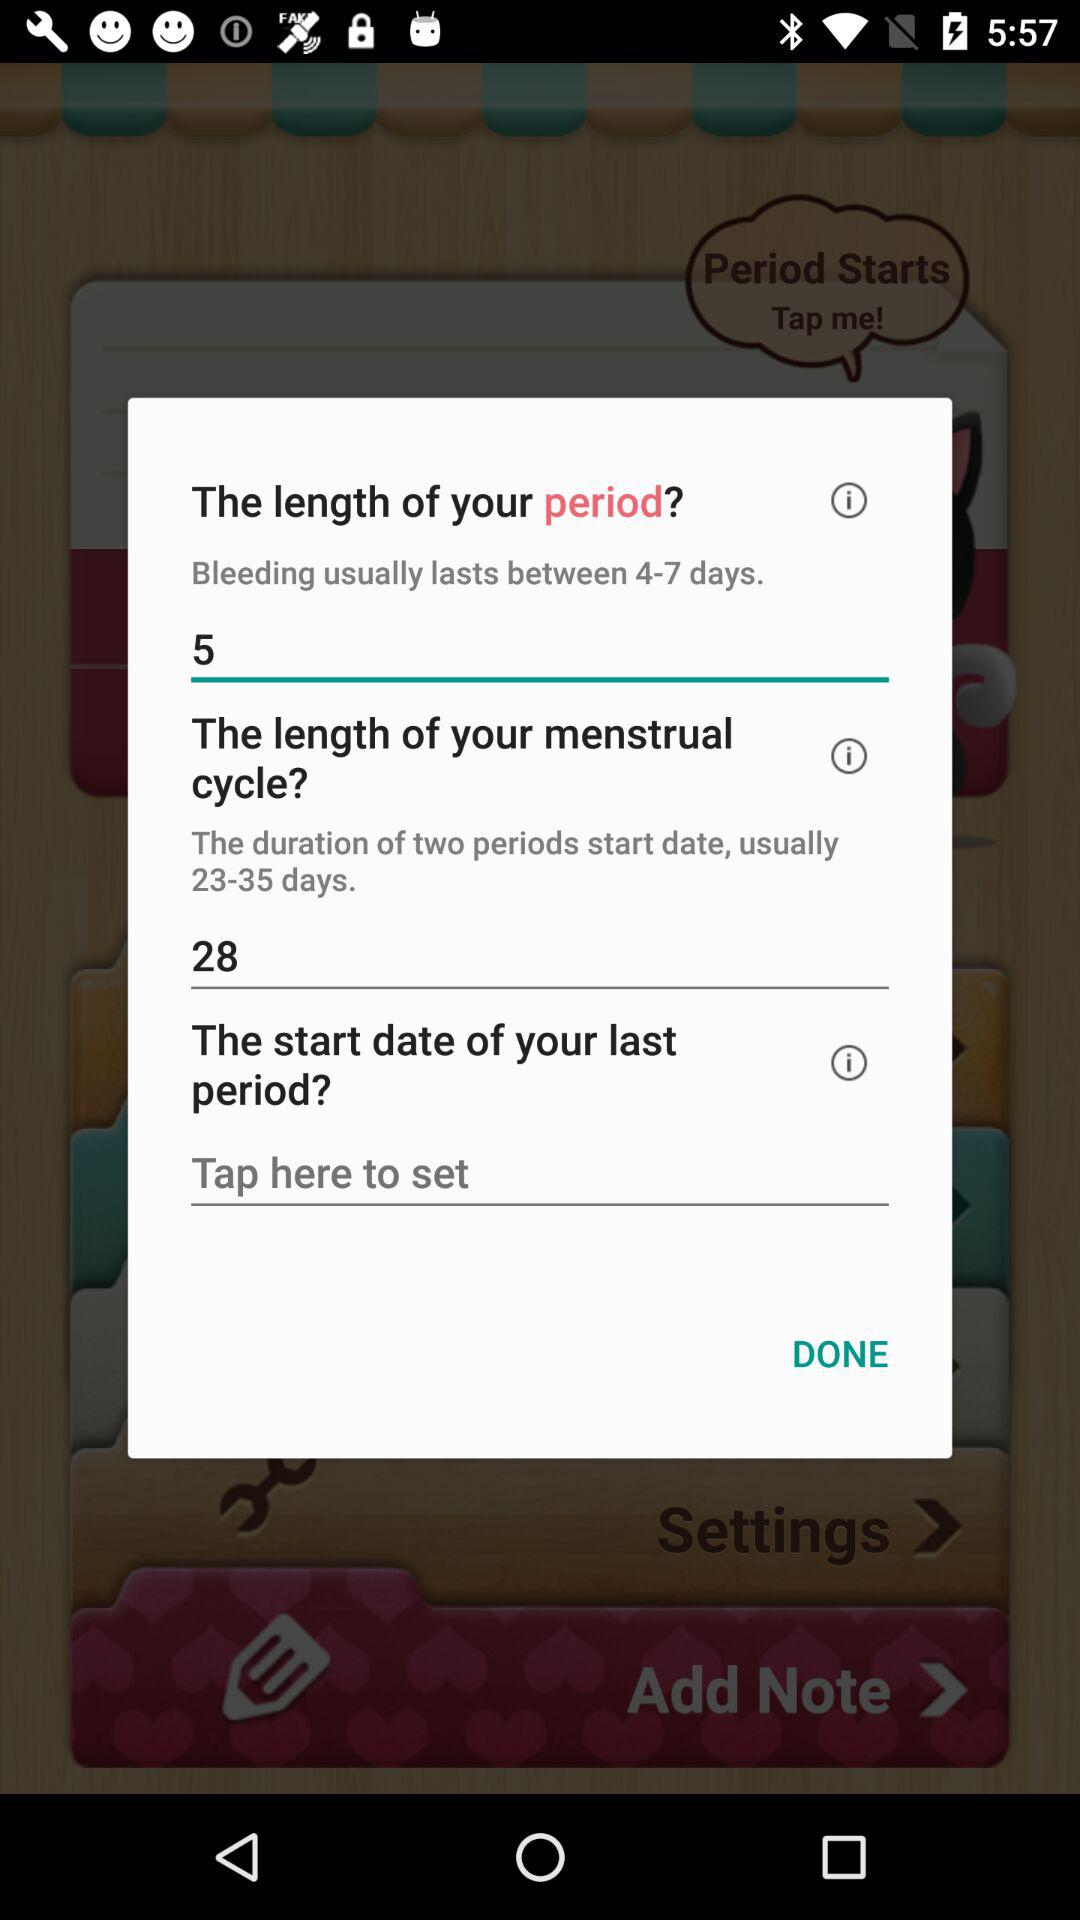How many days longer is the user's menstrual cycle than their period?
Answer the question using a single word or phrase. 23 